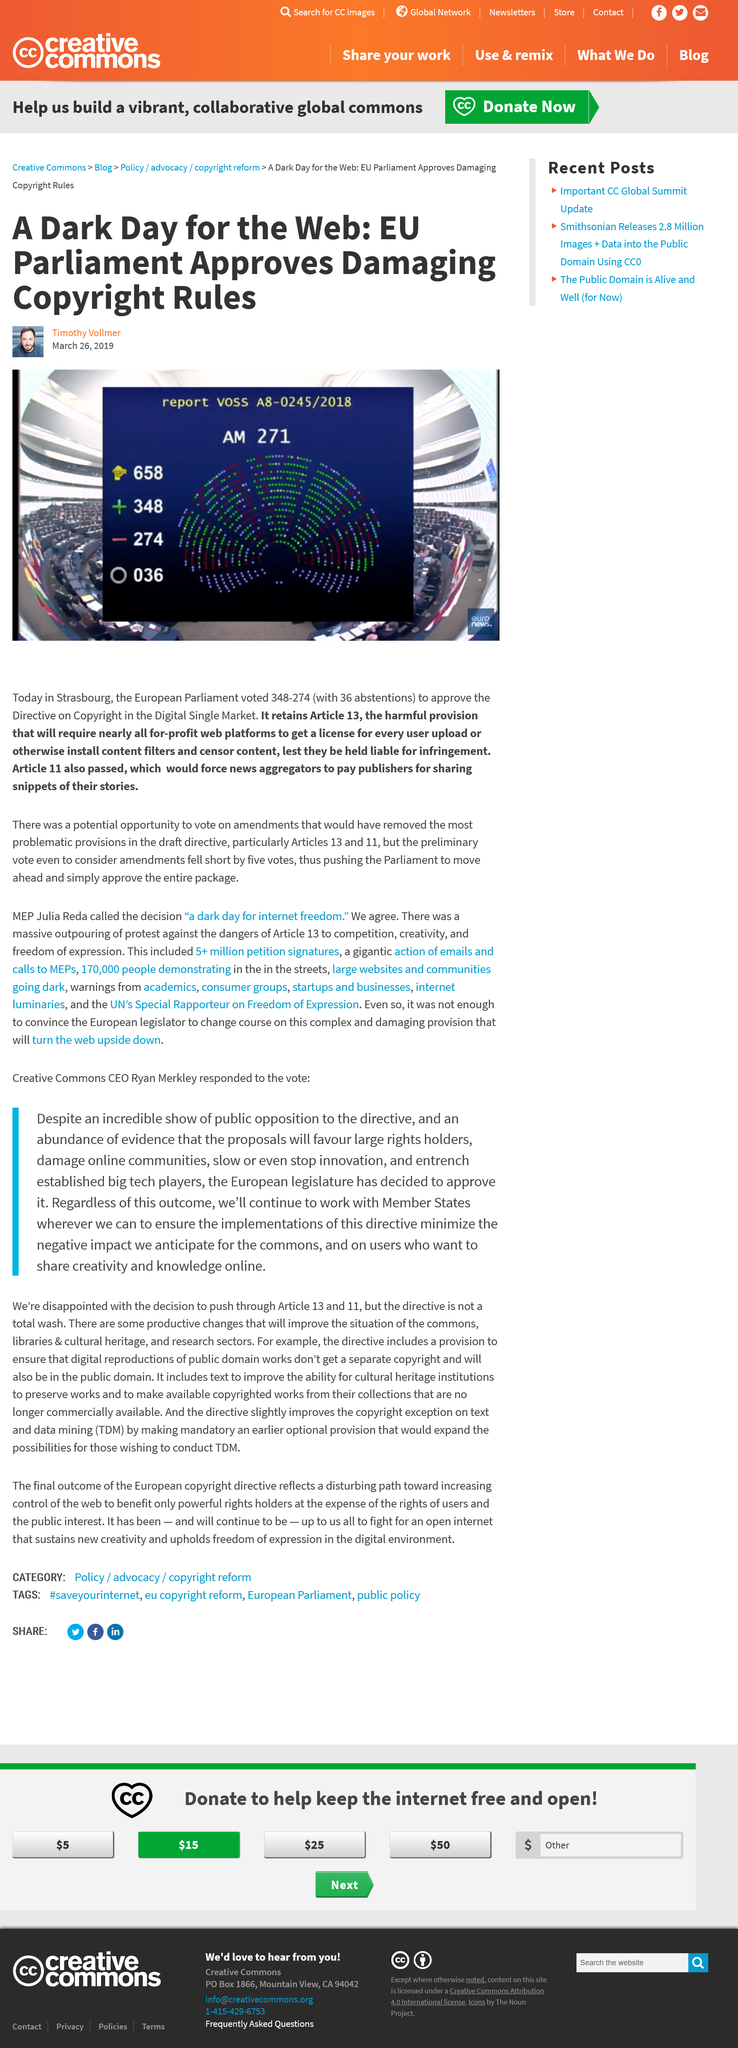Mention a couple of crucial points in this snapshot. The article was written by Timothy Vollmer. 658 individuals cast their votes in the European Parliament elections. There were 36 abstentions in the European Parliament. 